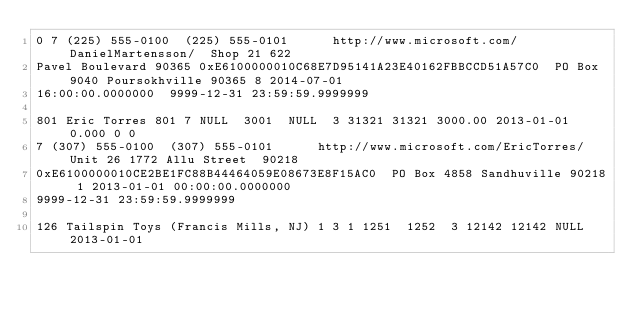<code> <loc_0><loc_0><loc_500><loc_500><_SQL_>0	7	(225) 555-0100	(225) 555-0101			http://www.microsoft.com/DanielMartensson/	Shop 21	622 
Pavel Boulevard	90365	0xE6100000010C68E7D95141A23E40162FBBCCD51A57C0	PO Box 9040	Poursokhville	90365	8	2014-07-01 
16:00:00.0000000	9999-12-31 23:59:59.9999999

801	Eric Torres	801	7	NULL	3001	NULL	3	31321	31321	3000.00	2013-01-01	0.000	0	0	
7	(307) 555-0100	(307) 555-0101			http://www.microsoft.com/EricTorres/	Unit 26	1772 Allu Street	90218	
0xE6100000010CE2BE1FC88B44464059E08673E8F15AC0	PO Box 4858	Sandhuville	90218	1	2013-01-01 00:00:00.0000000	
9999-12-31 23:59:59.9999999

126	Tailspin Toys (Francis Mills, NJ)	1	3	1	1251	1252	3	12142	12142	NULL	2013-01-01	</code> 